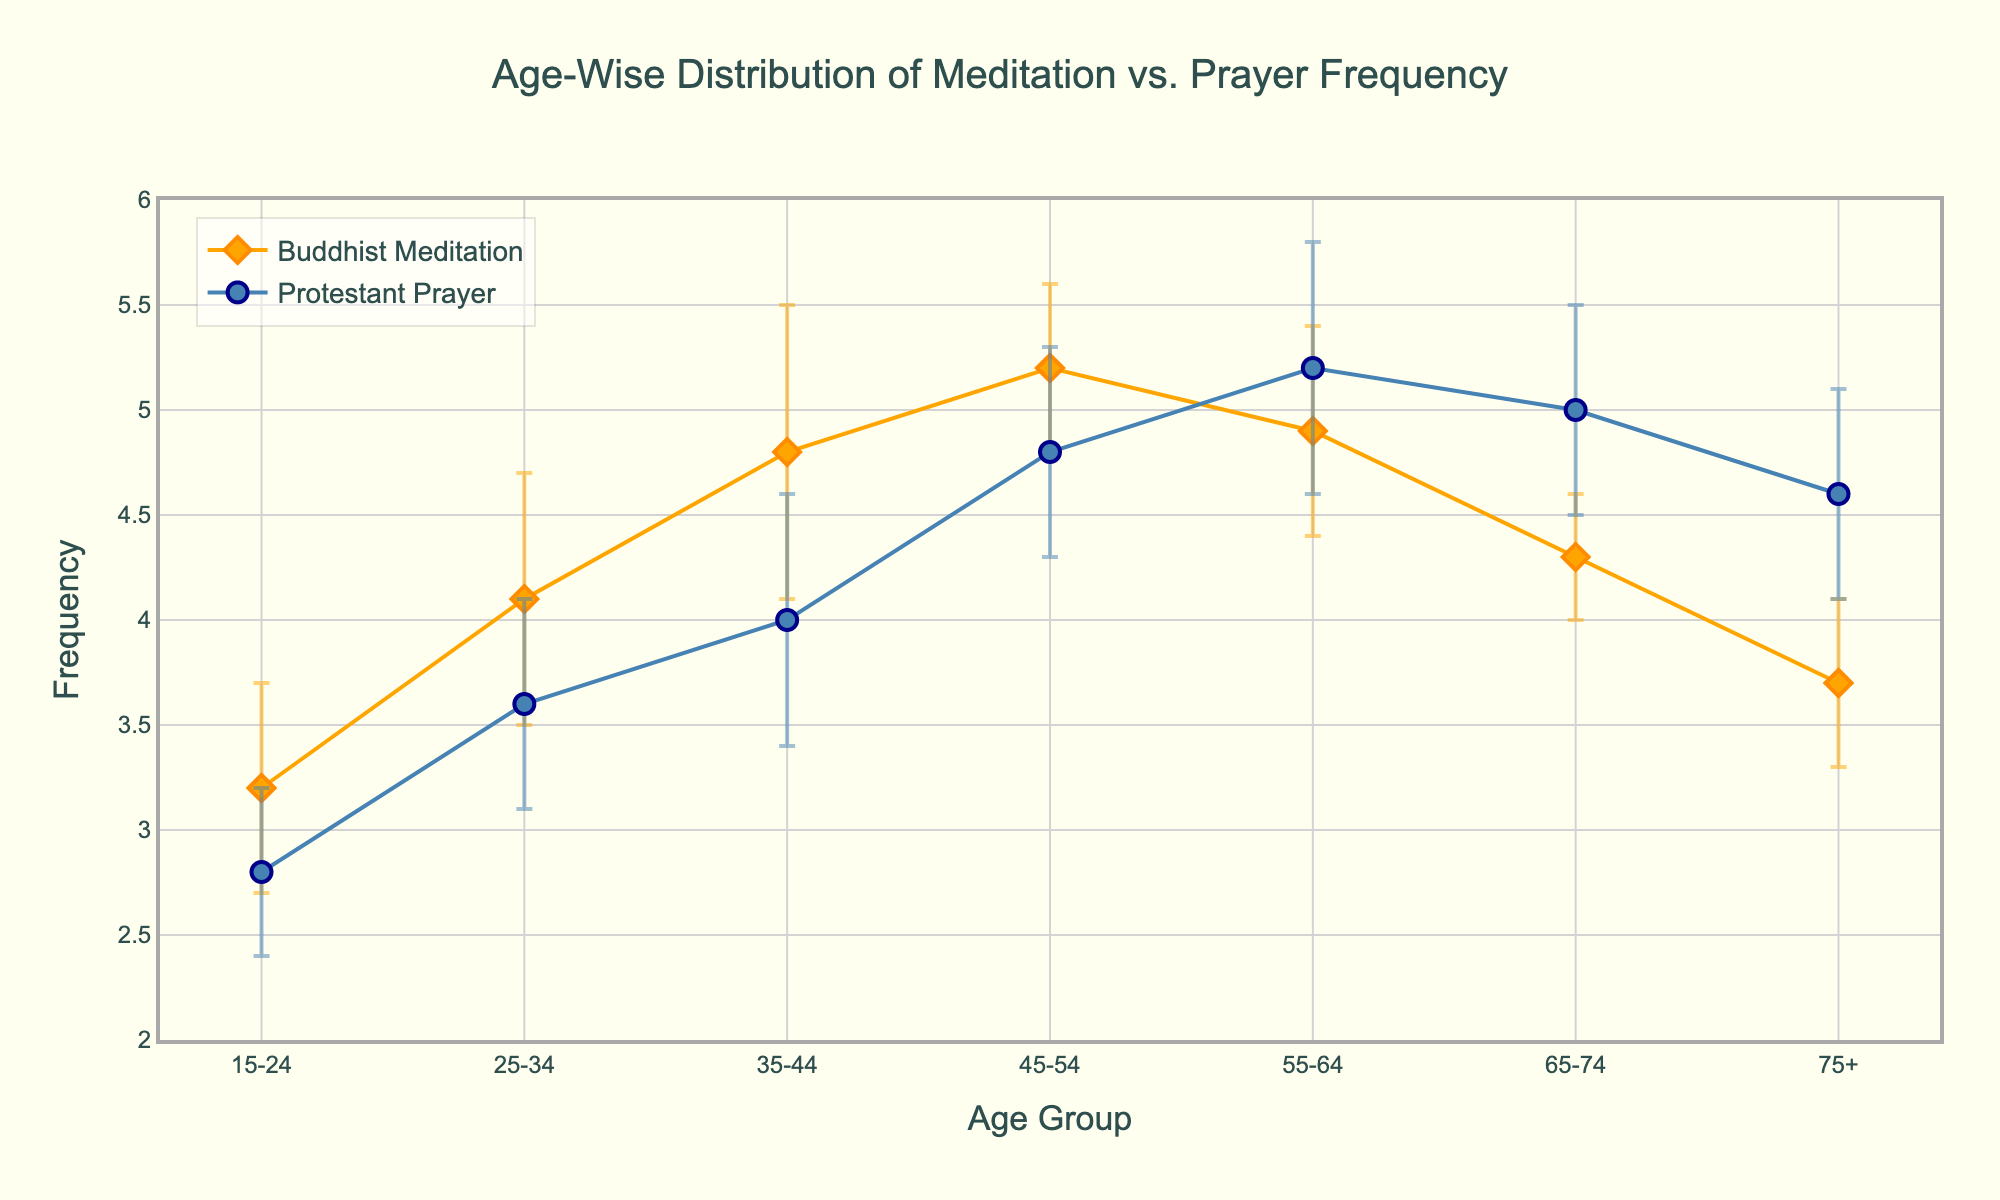What is the title of the plot? The title is usually located at the top of the figure, often stylized to help the viewer understand what the figure is about. In this plot, it should be clearly visible at the top.
Answer: Age-Wise Distribution of Meditation vs. Prayer Frequency What are the age groups displayed on the x-axis? The x-axis labels represent different age groups. By reading these labels from left to right, we can identify all age groups included in the figure.
Answer: 15-24, 25-34, 35-44, 45-54, 55-64, 65-74, 75+ Which group has the highest frequency of their spiritual practice? By examining the peaks of both lines, we can determine which group has the highest maximum value. The highest point on the y-axis for Buddhism shows the meditation frequency, and for Protestantism, the prayer frequency.
Answer: Buddhist group (45-54) In the 45-54 age group, how do the meditation and prayer frequencies compare? By looking at the y-values for the 45-54 age group markers for both Buddhists and Protestants, we can directly compare the two frequencies.
Answer: Meditation is 5.2, Prayer is 4.8 What is the trend of meditation frequency in the Buddhist group as age increases? Observing the orange line and its direction from left to right helps us understand the behavior across age groups. We note whether the trend is increasing, decreasing, or fluctuating.
Answer: Increases until 45-54, then decreases At what age group is the prayer frequency highest for Protestants? By identifying the peak value of the blue line and finding the corresponding age group on the x-axis, we can answer this question.
Answer: 55-64 Between which age groups is there a noticeable decrease in both meditation and prayer frequencies? By comparing consecutive points on both lines and observing noticeable drops, we identify the age groups where both frequencies decrease.
Answer: 55-64 to 65-74 Which age group shows the least difference between meditation and prayer frequency? We need to calculate the absolute differences in frequencies for each age group and identify the group with the smallest difference. This involves comparing values and subtracting one from the other for each pair.
Answer: 25-34 How do the error bars for meditation frequency compare to those for prayer frequency? Error bars provide a visual indication of variability. Comparing the lengths and colors of the orange and blue error bars for each age group summarizes their differences.
Answer: Meditation error bars are generally longer What is the frequency range observed on the y-axis? By looking at the y-axis labels and grid lines, we can determine the lowest and highest frequencies plotted on the figure. This helps understand the scale used.
Answer: 2 to 6 